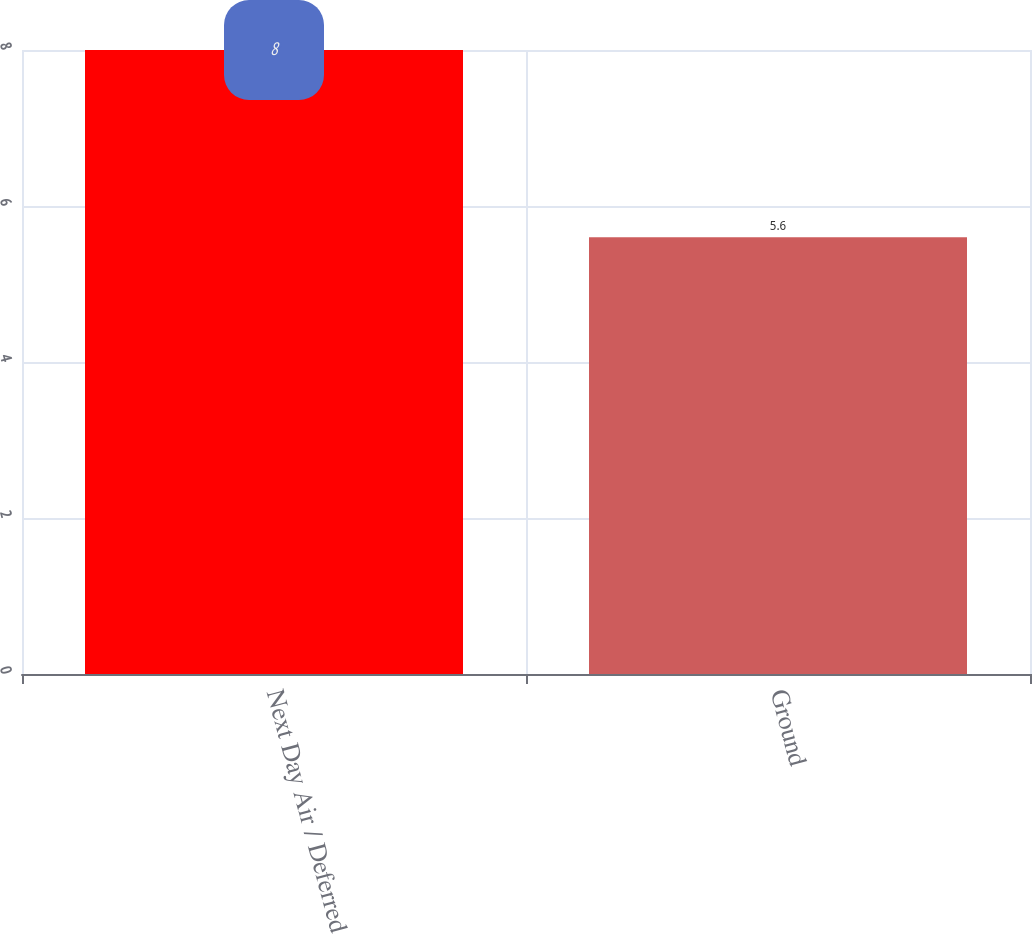<chart> <loc_0><loc_0><loc_500><loc_500><bar_chart><fcel>Next Day Air / Deferred<fcel>Ground<nl><fcel>8<fcel>5.6<nl></chart> 